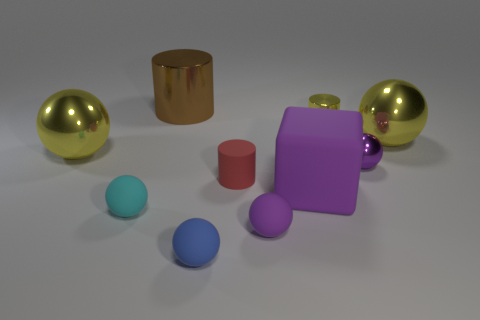Subtract 1 spheres. How many spheres are left? 5 Subtract all cyan spheres. How many spheres are left? 5 Subtract all blue spheres. How many spheres are left? 5 Subtract all green spheres. Subtract all cyan blocks. How many spheres are left? 6 Subtract all balls. How many objects are left? 4 Subtract all small blue things. Subtract all matte cubes. How many objects are left? 8 Add 8 red matte cylinders. How many red matte cylinders are left? 9 Add 8 big blue matte cylinders. How many big blue matte cylinders exist? 8 Subtract 0 gray cylinders. How many objects are left? 10 